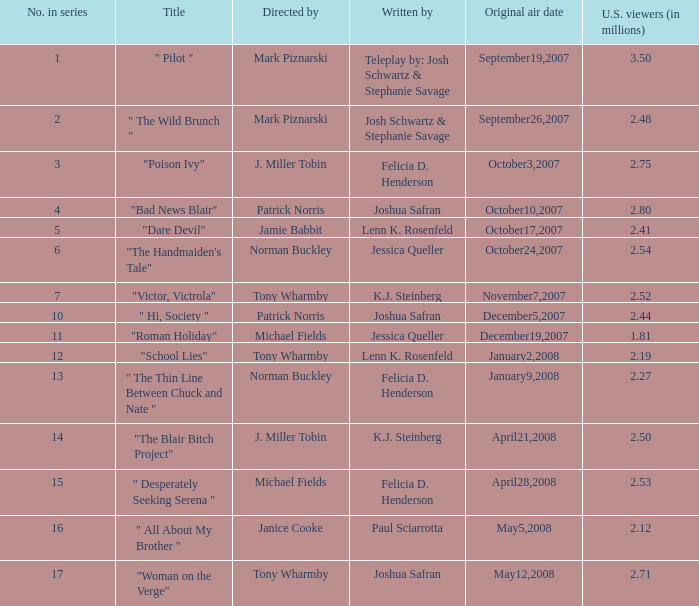What is the name when "The Blair Bitch Project". 